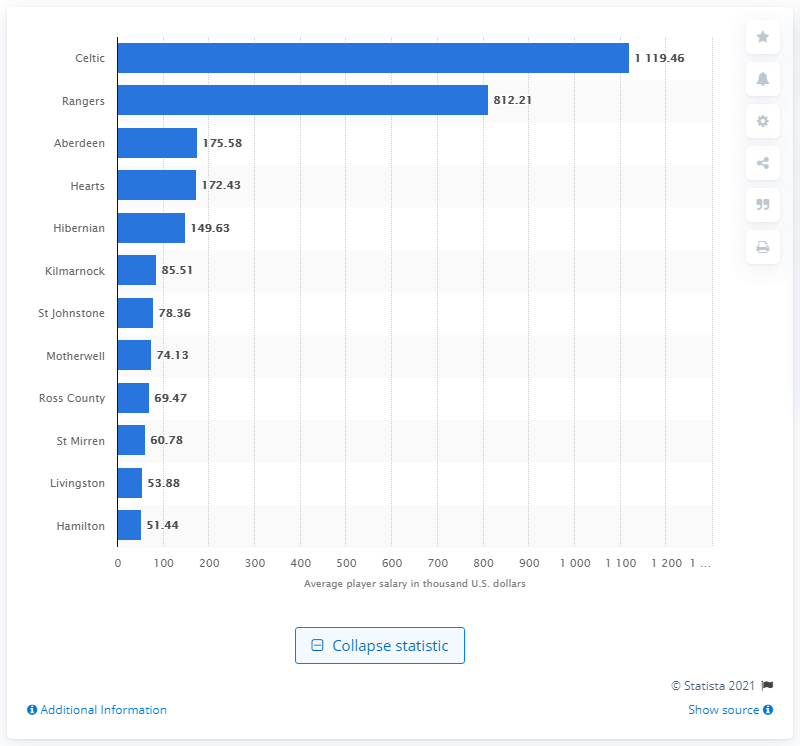List a handful of essential elements in this visual. The Scottish Premiership club Hamilton is reportedly the lowest paying club in the league, according to recent reports. In the 2019/2020 Scottish Premiership season, Celtic was the team that was highest paid. 